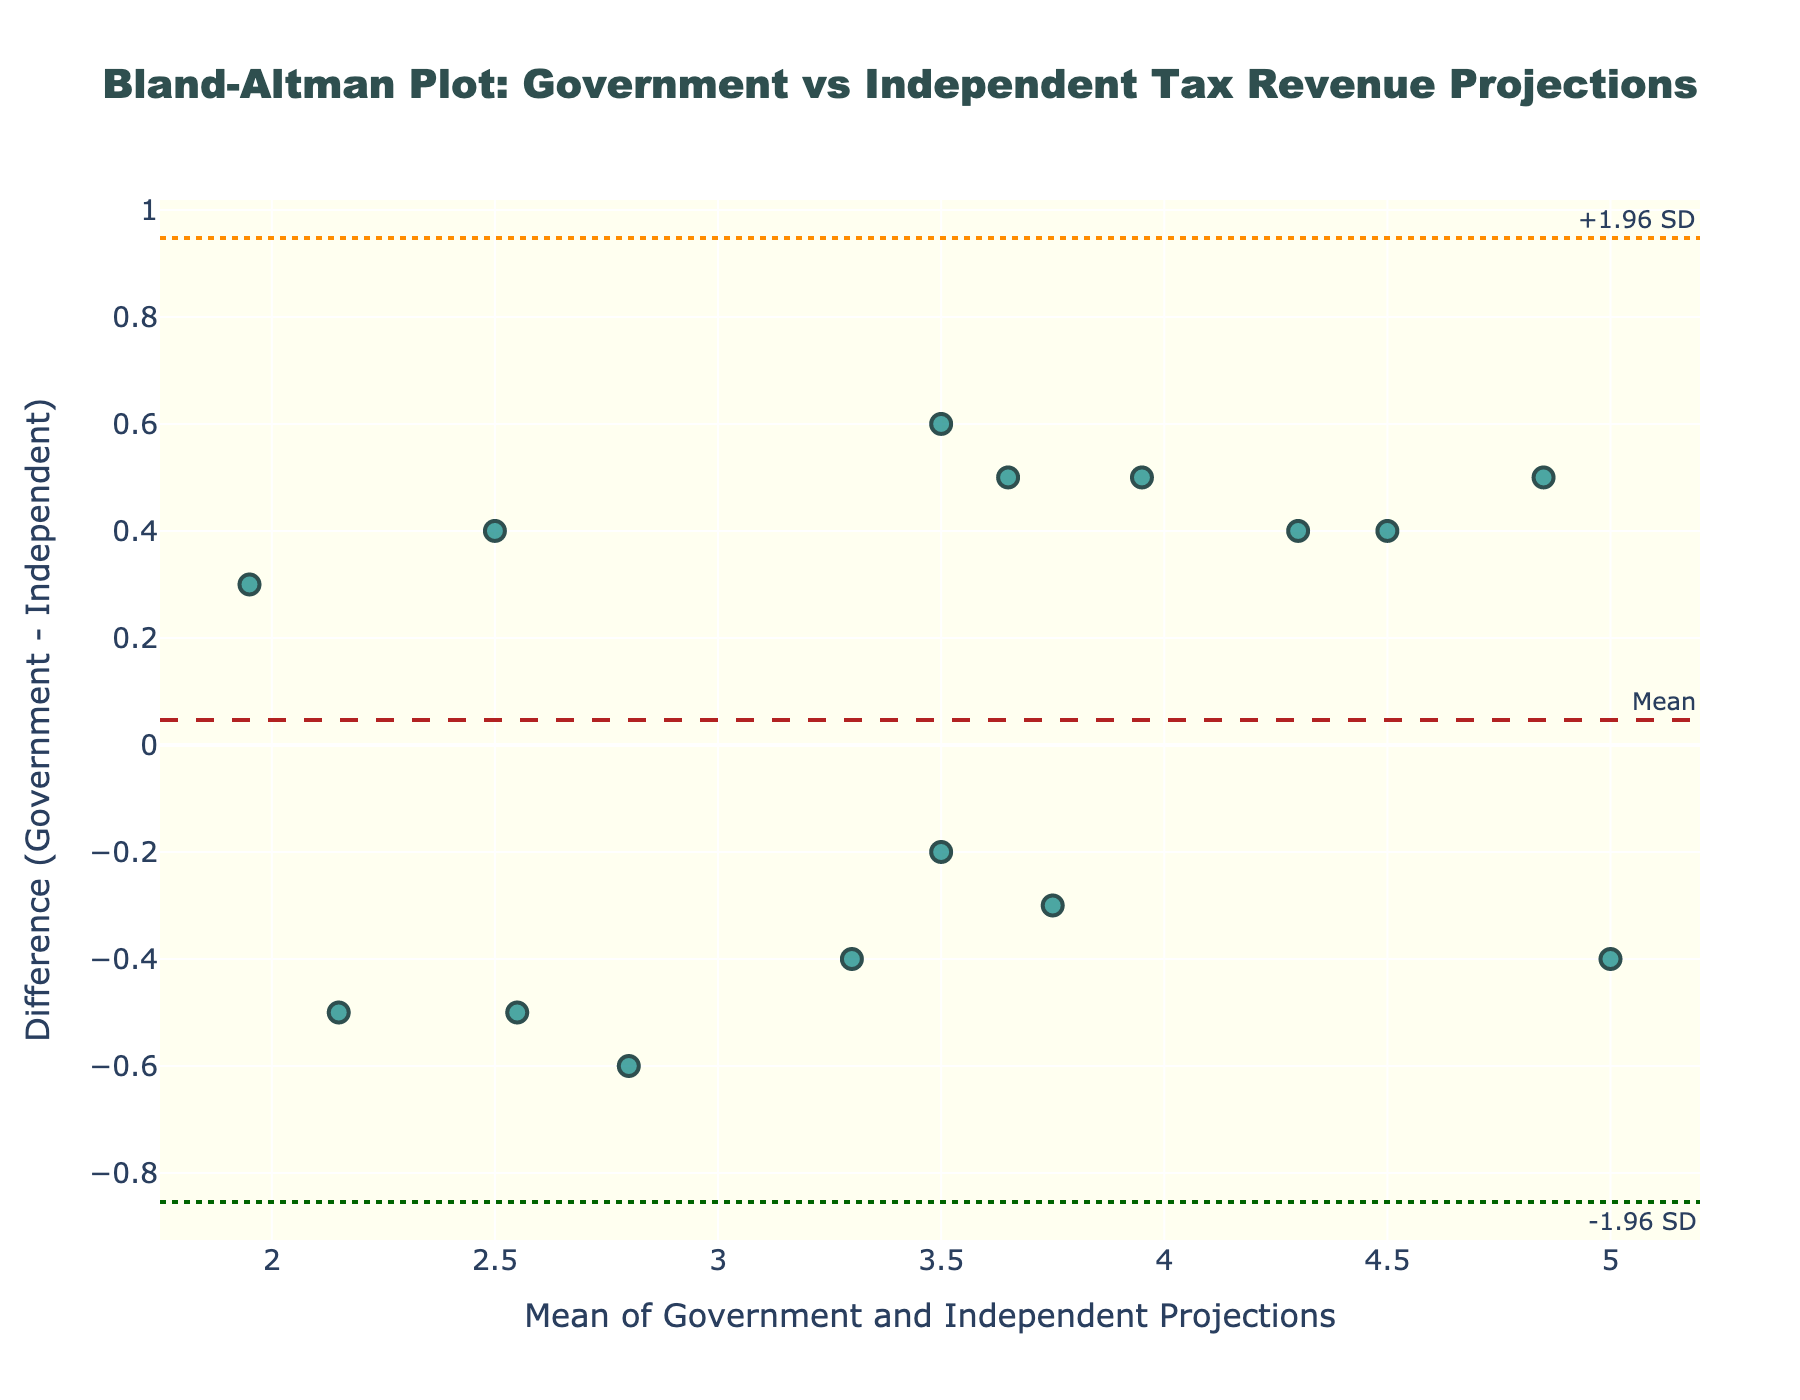What is the title of the figure? The title is typically placed at the top of the plot. Here, it states the purpose of the plot and what it compares.
Answer: Bland-Altman Plot: Government vs Independent Tax Revenue Projections How many data points are shown in the plot? By counting the markers (dots) on the plot, we can determine the total number of data points.
Answer: 15 What color are the data points? Observing the figure, you can see the color used for the markers.
Answer: Teal What does the x-axis represent? The labels and title on the x-axis indicate what it represents, usually mentioned during the data analysis.
Answer: Mean of Government and Independent Projections What is the y-axis title? This can be found by looking at the axis label on the left side of the plot.
Answer: Difference (Government - Independent) What is the mean difference between the projections? The mean difference is typically indicated by a dashed line, annotated on the plot as "Mean."
Answer: 0.18 What are the upper and lower limits of agreement? The limits of agreement are generally shown as horizontal lines, annotated with +1.96 SD and -1.96 SD.
Answer: Upper: 1.02, Lower: -0.66 Is there more variability in the positive or negative differences? By observing the dispersion of points above and below the zero line, we can note which side has more spread.
Answer: More variability in the positive differences How many data points fall outside the limits of agreement? Count the number of points that are above the +1.96 SD line or below the -1.96 SD line.
Answer: 0 Are there any projections where the independent analyst predicted higher than the government? Points below the zero line indicate where the independent projection is higher than the government projection. Count these points.
Answer: 5 